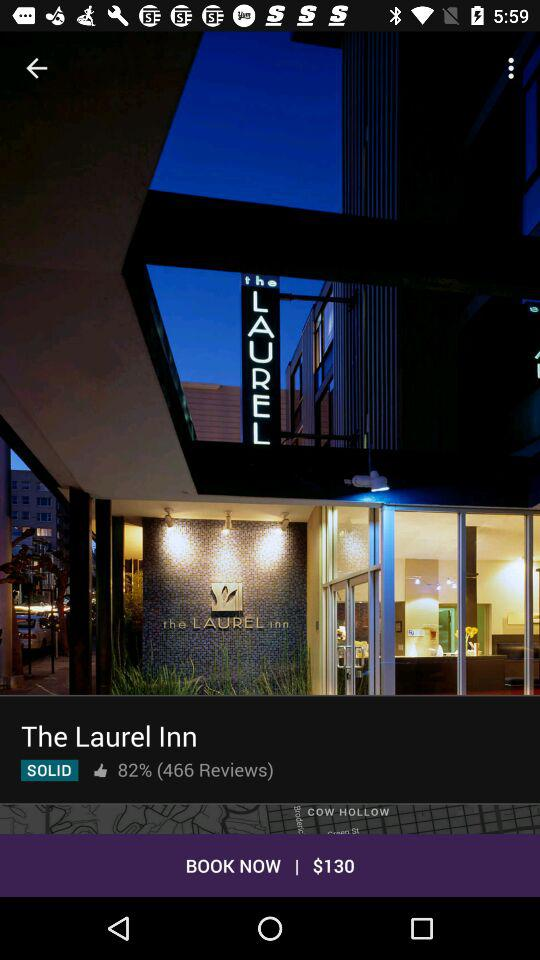What is the total number of reviews for the hotel? The total number of reviews for the hotel is 466. 